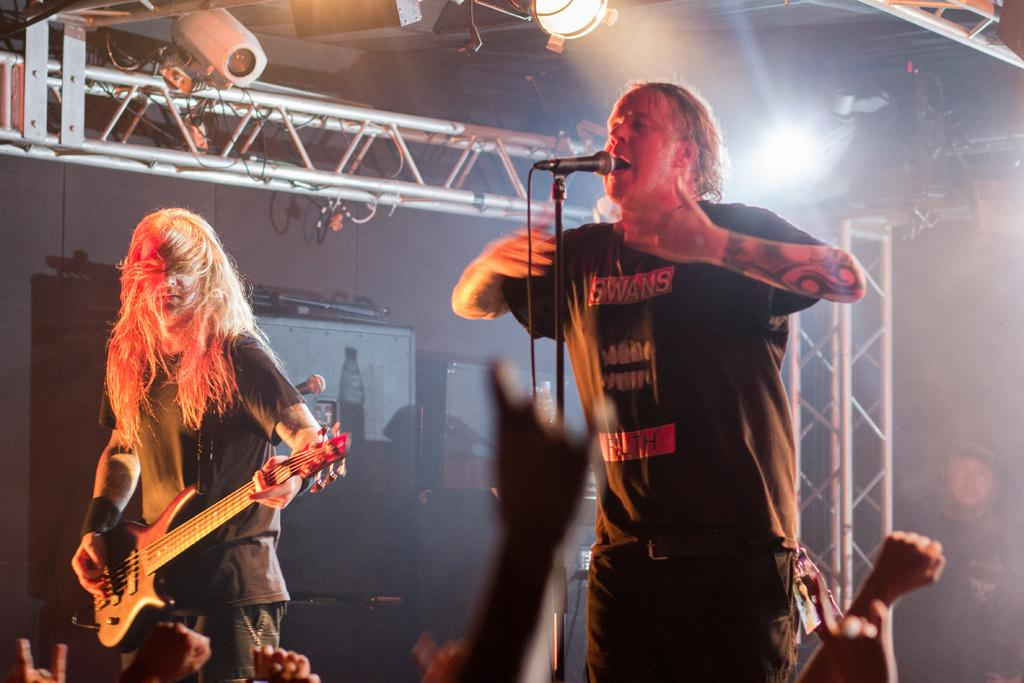How many people are in the image? There are two persons standing in the image. What is one person doing in the image? One person is playing a guitar. What else is the person with the guitar doing? The person playing the guitar is also singing into a microphone. What can be seen in the background of the image? There is a wall in the background of the image. How would you describe the lighting in the background? The background is well-lit. How much payment is being made for the performance in the image? There is no indication of payment being made in the image. What type of bushes can be seen in the image? There are no bushes present in the image. 